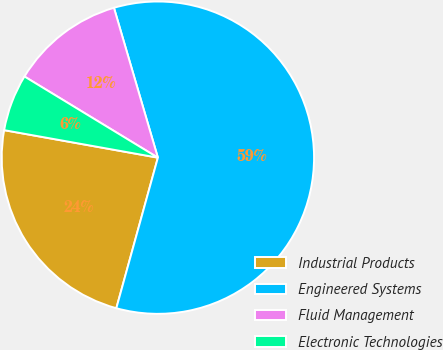Convert chart to OTSL. <chart><loc_0><loc_0><loc_500><loc_500><pie_chart><fcel>Industrial Products<fcel>Engineered Systems<fcel>Fluid Management<fcel>Electronic Technologies<nl><fcel>23.53%<fcel>58.82%<fcel>11.76%<fcel>5.88%<nl></chart> 